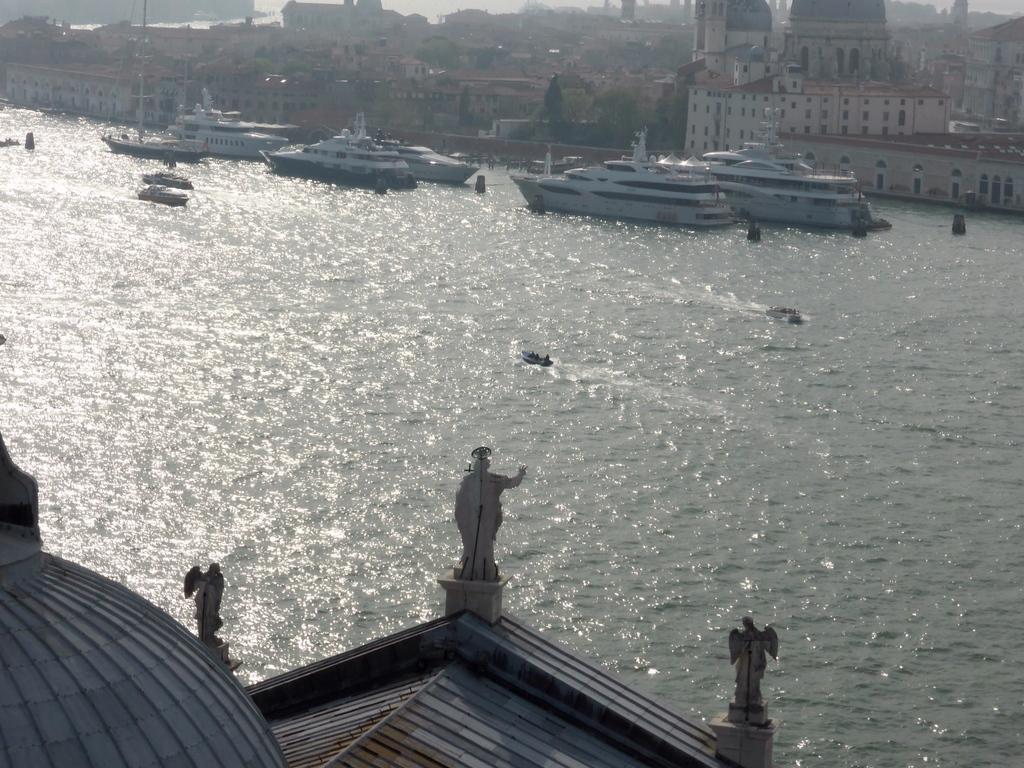Could you give a brief overview of what you see in this image? In the front of the image there are statues. In the middle of the image there is water, ships and boards. In the background of the image there are buildings and trees.   